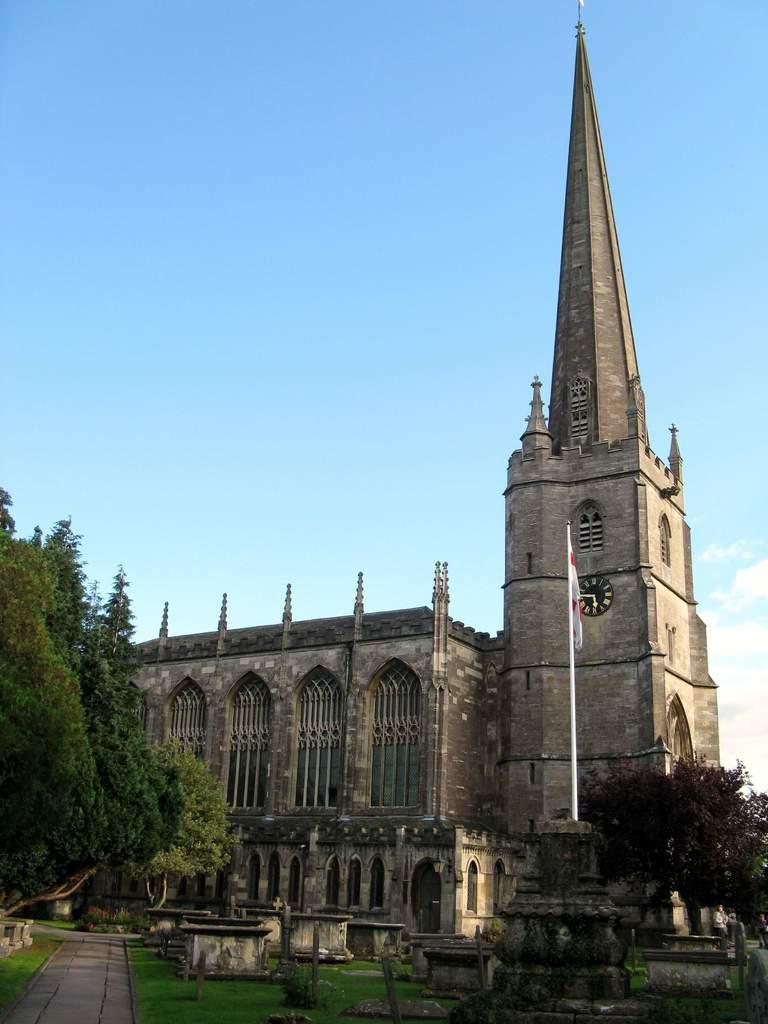Can you describe this image briefly? In the foreground of this image, there is a path, grass and, few poles, trees and a flag. In the middle, there is a building. In the background, there is the sky and the cloud. 